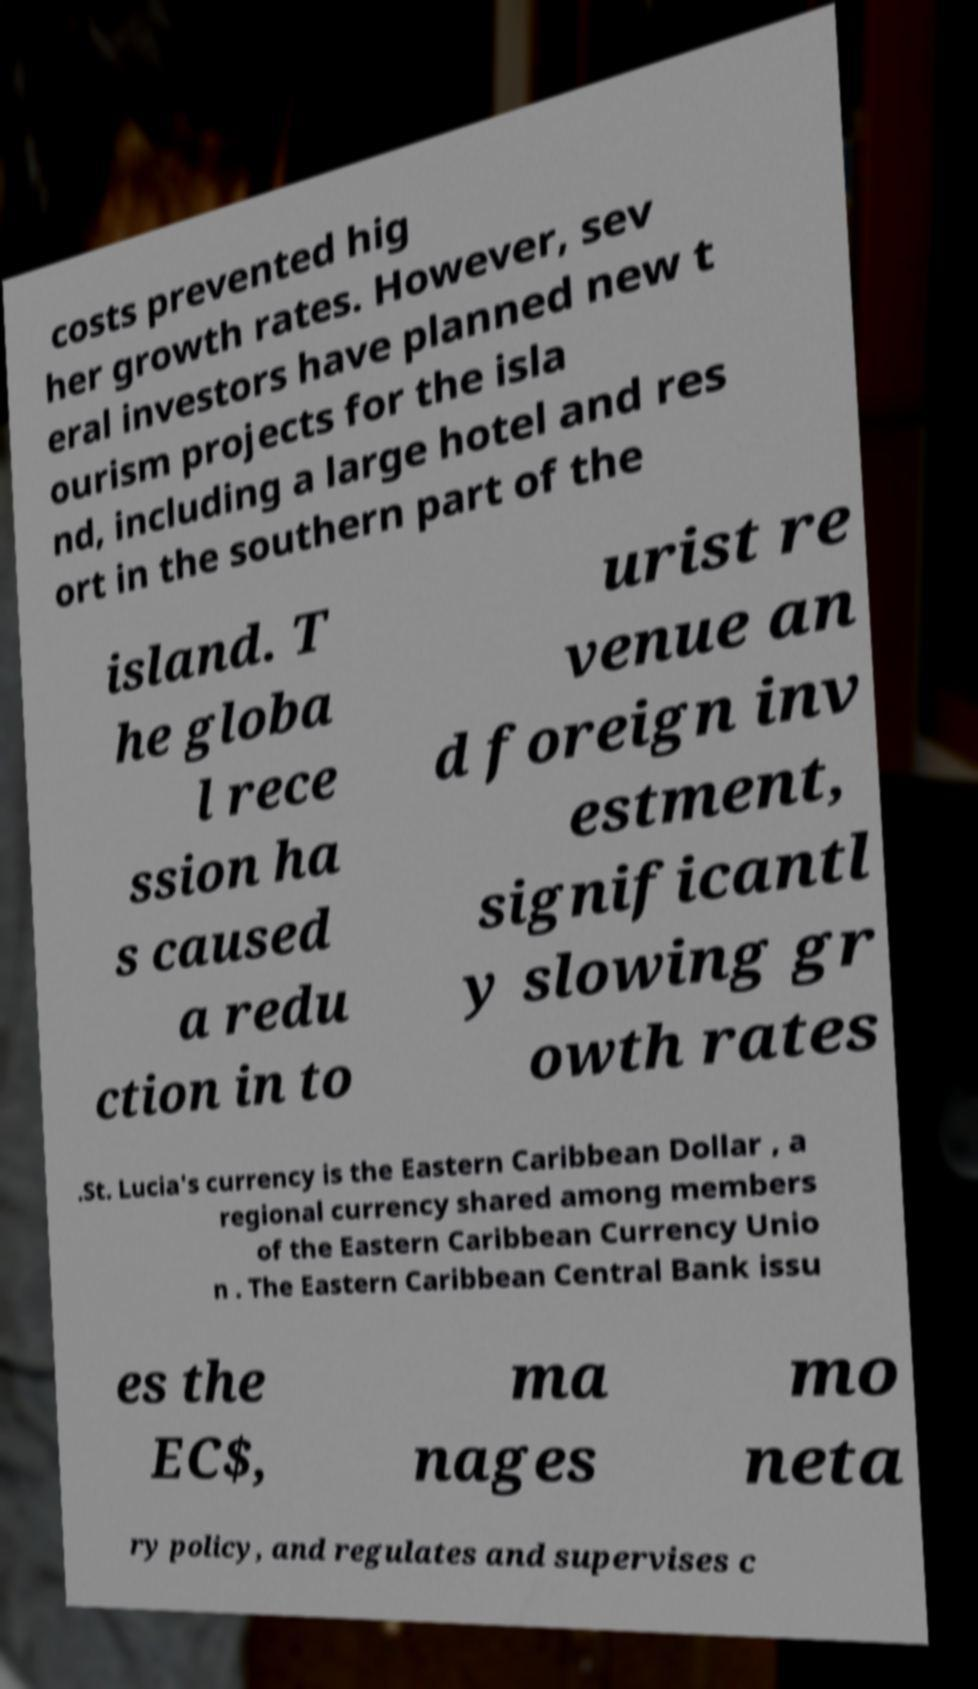Please identify and transcribe the text found in this image. costs prevented hig her growth rates. However, sev eral investors have planned new t ourism projects for the isla nd, including a large hotel and res ort in the southern part of the island. T he globa l rece ssion ha s caused a redu ction in to urist re venue an d foreign inv estment, significantl y slowing gr owth rates .St. Lucia's currency is the Eastern Caribbean Dollar , a regional currency shared among members of the Eastern Caribbean Currency Unio n . The Eastern Caribbean Central Bank issu es the EC$, ma nages mo neta ry policy, and regulates and supervises c 